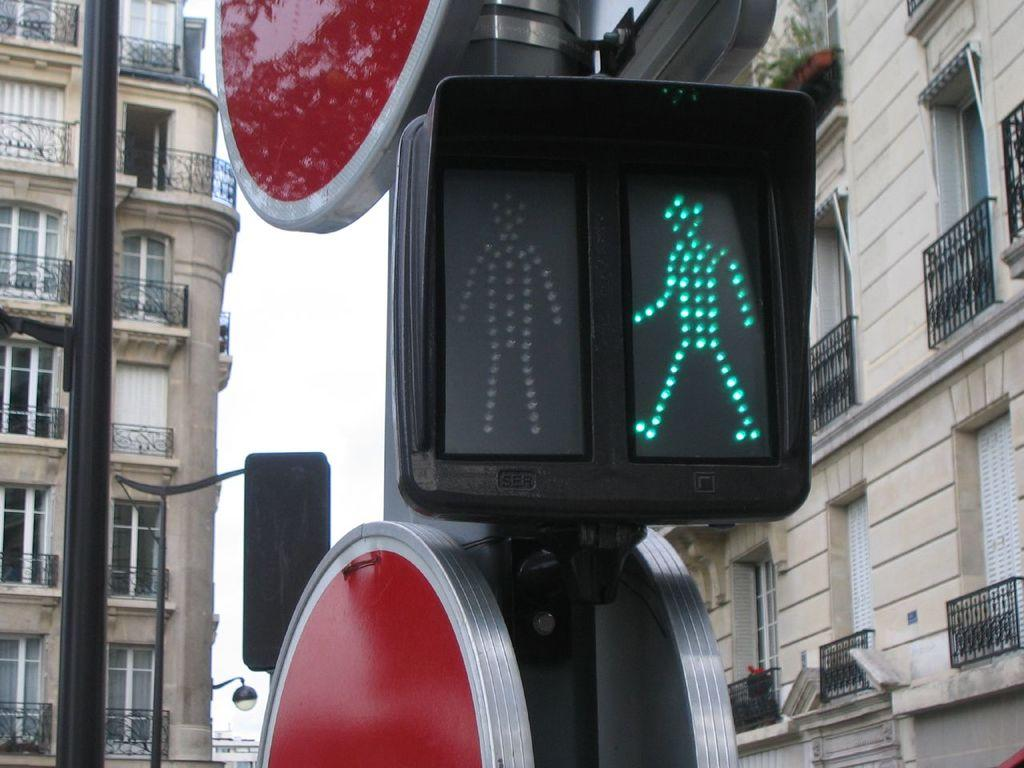What is located in the foreground of the image? There is a pole with a display sign board in the foreground of the image. What can be seen in the background of the image? There is a group of buildings in the background of the image. What type of railings do the buildings have? The buildings have metal railings. What is visible in the background of the image besides the buildings? The sky is visible in the background of the image. Can you see a kite flying at the top of the buildings in the image? There is no kite visible at the top of the buildings in the image. Is there a fight happening between the buildings in the image? There is no fight depicted between the buildings in the image; they are simply standing in the background. 